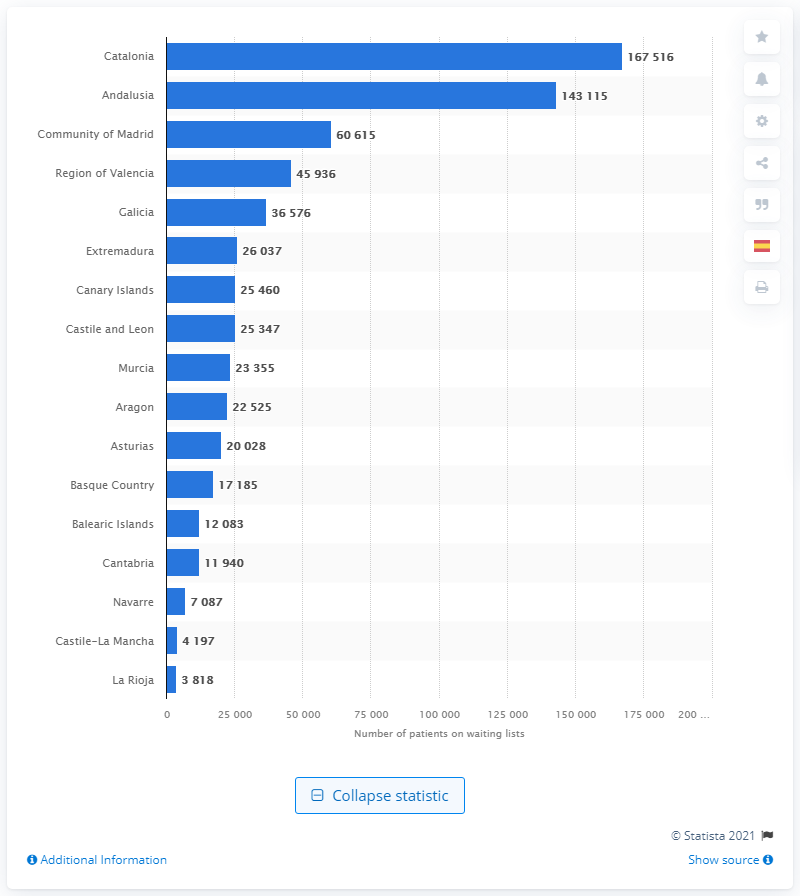Point out several critical features in this image. In 2020, there were 167,516 patients waiting for surgery in Andalusia. 